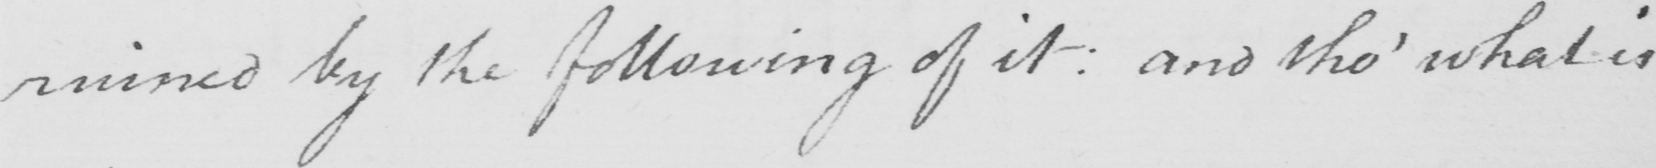Please transcribe the handwritten text in this image. ruined by the following of it :  and tho '  what is 